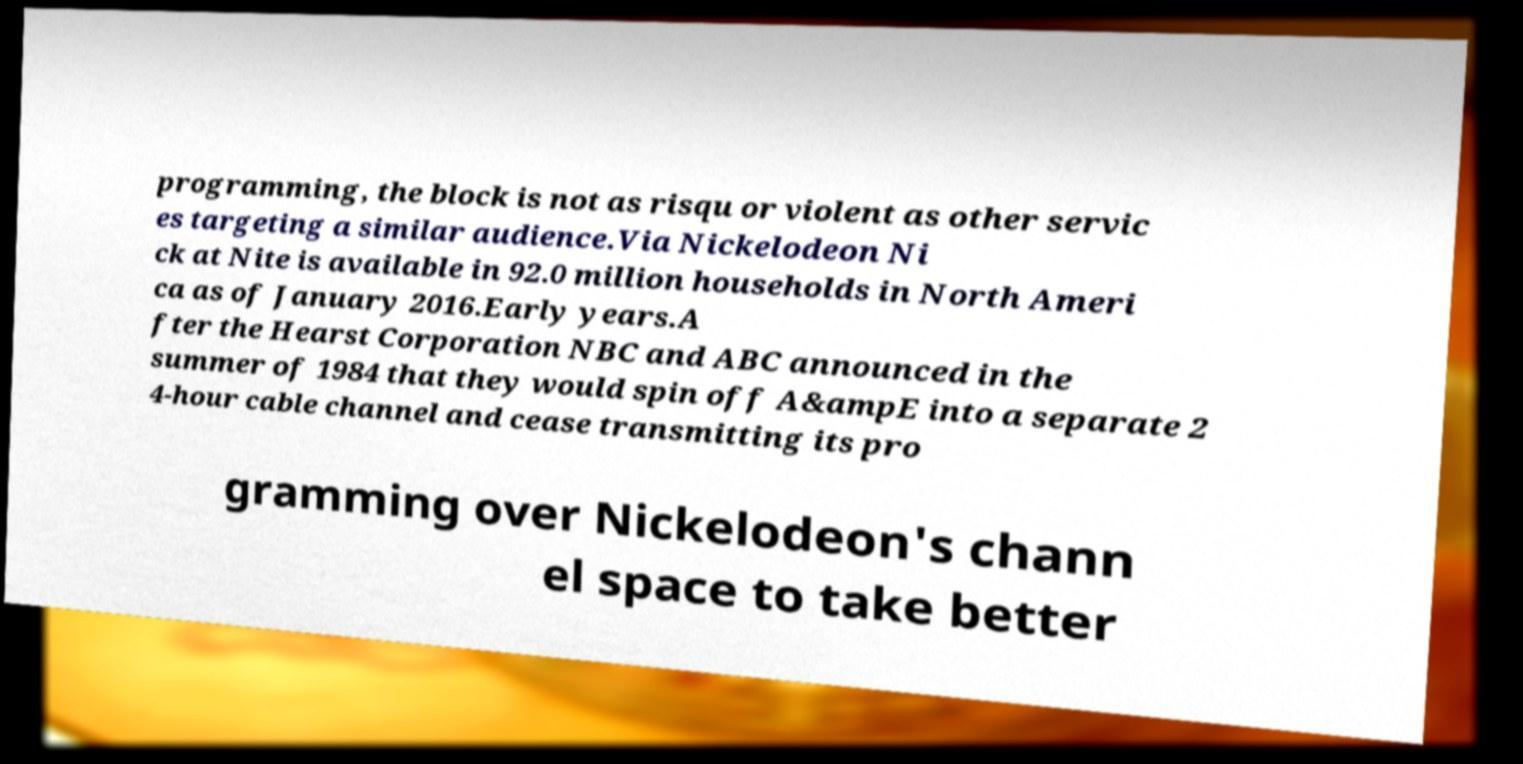For documentation purposes, I need the text within this image transcribed. Could you provide that? programming, the block is not as risqu or violent as other servic es targeting a similar audience.Via Nickelodeon Ni ck at Nite is available in 92.0 million households in North Ameri ca as of January 2016.Early years.A fter the Hearst Corporation NBC and ABC announced in the summer of 1984 that they would spin off A&ampE into a separate 2 4-hour cable channel and cease transmitting its pro gramming over Nickelodeon's chann el space to take better 